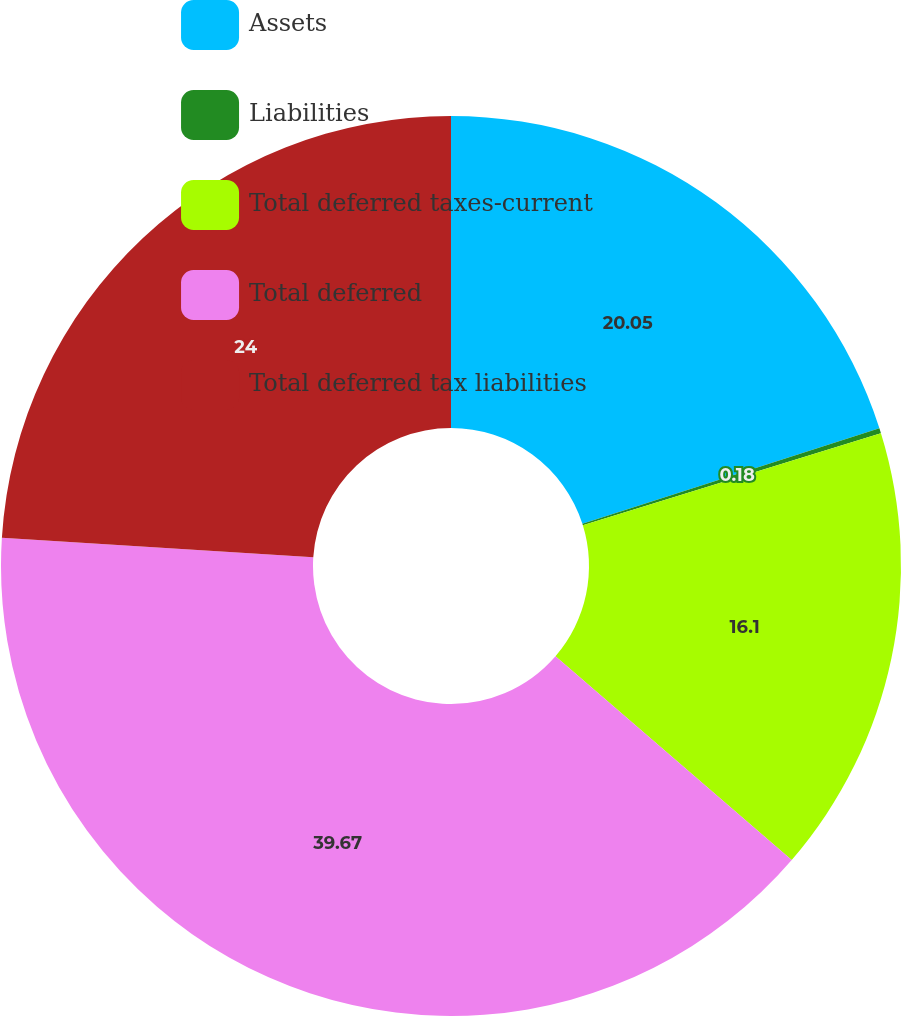Convert chart to OTSL. <chart><loc_0><loc_0><loc_500><loc_500><pie_chart><fcel>Assets<fcel>Liabilities<fcel>Total deferred taxes-current<fcel>Total deferred<fcel>Total deferred tax liabilities<nl><fcel>20.05%<fcel>0.18%<fcel>16.1%<fcel>39.67%<fcel>24.0%<nl></chart> 